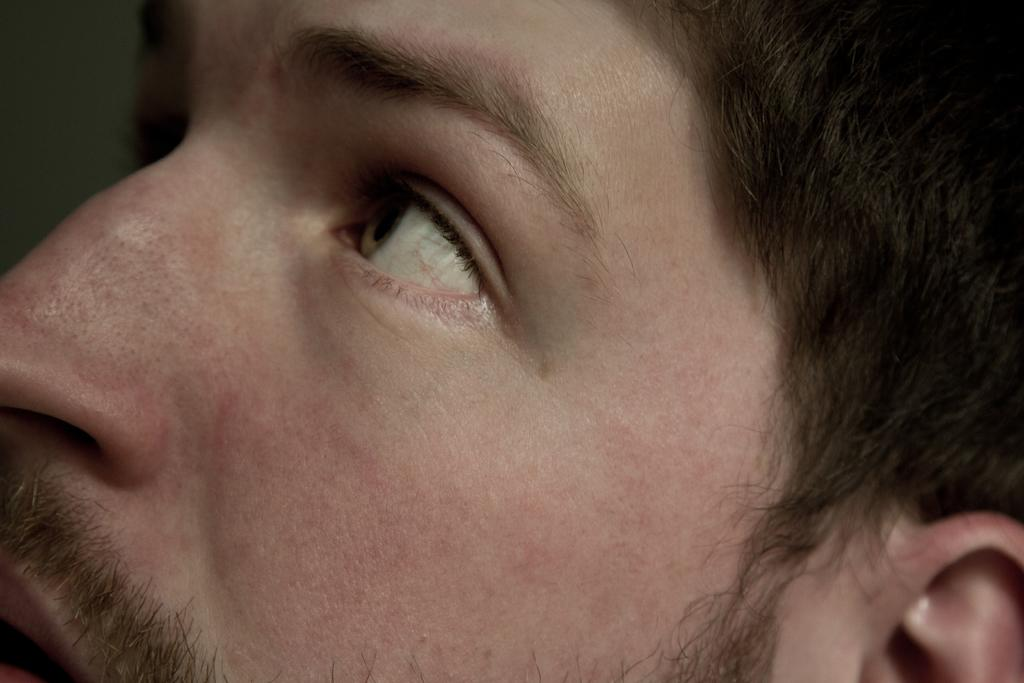What facial features are visible in the image? The image contains a person's eye, nose, and ear. What else can be seen in the image related to the person? The person's hair is also visible in the image. What direction is the person looking in the image? The person is looking at the corner of the image. How would you describe the background of the image? The background of the image is blurred. What type of ship can be seen sailing in the background of the image? There is no ship visible in the image; it only contains a person's eye, nose, ear, hair, and a blurred background. How many beans are present on the shelf in the image? There is no shelf or beans present in the image. 